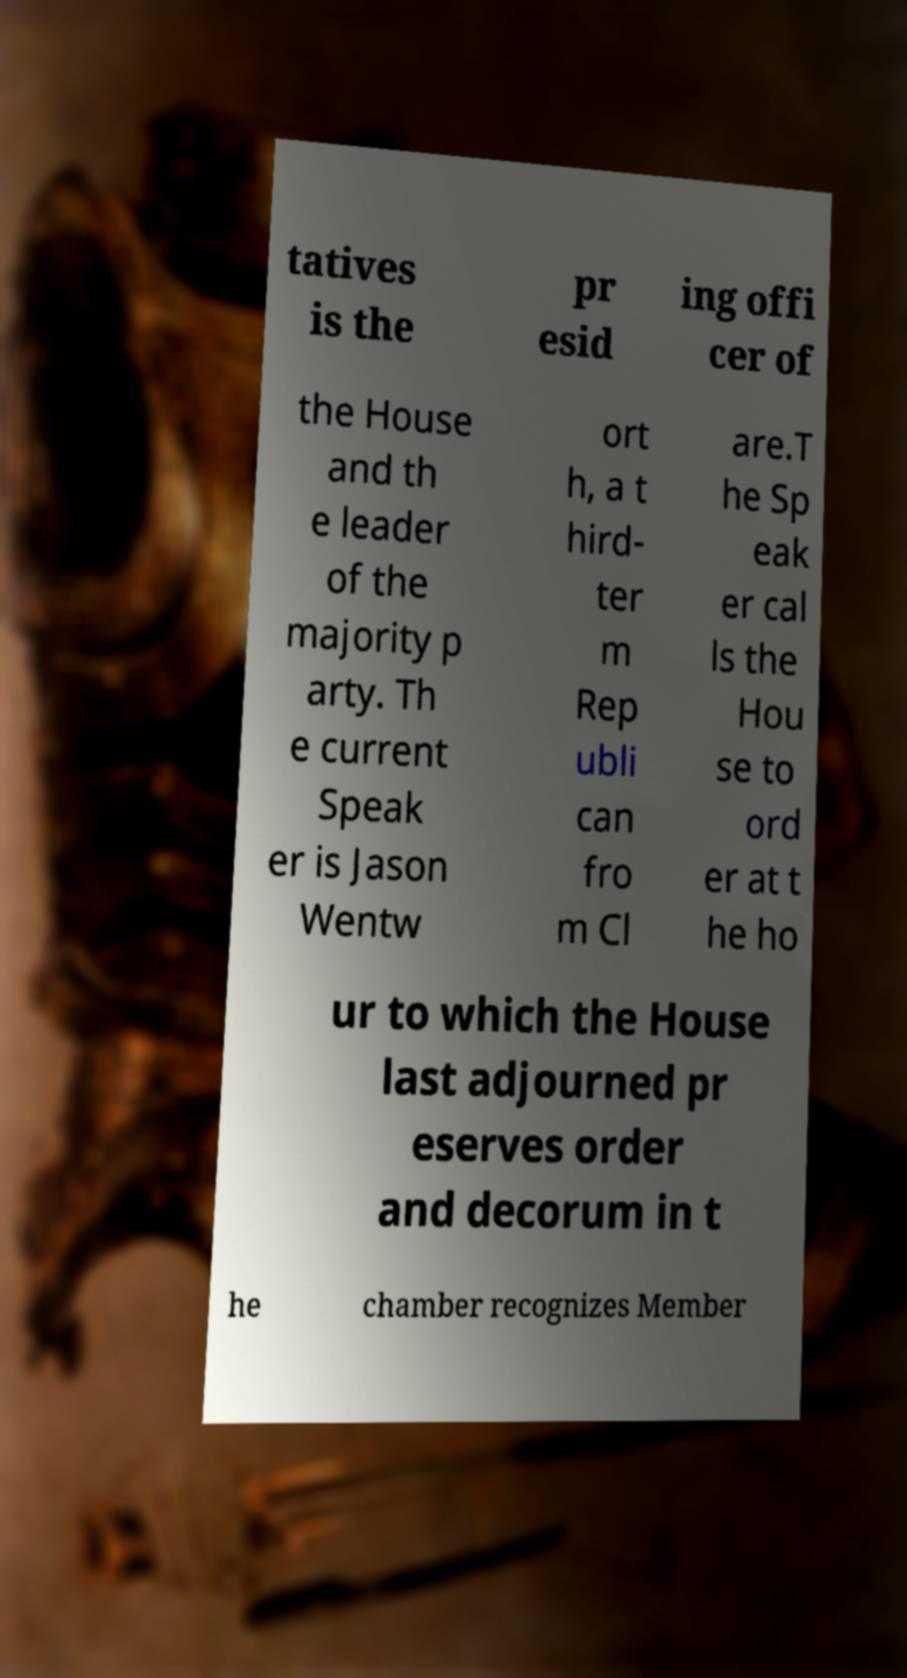There's text embedded in this image that I need extracted. Can you transcribe it verbatim? tatives is the pr esid ing offi cer of the House and th e leader of the majority p arty. Th e current Speak er is Jason Wentw ort h, a t hird- ter m Rep ubli can fro m Cl are.T he Sp eak er cal ls the Hou se to ord er at t he ho ur to which the House last adjourned pr eserves order and decorum in t he chamber recognizes Member 